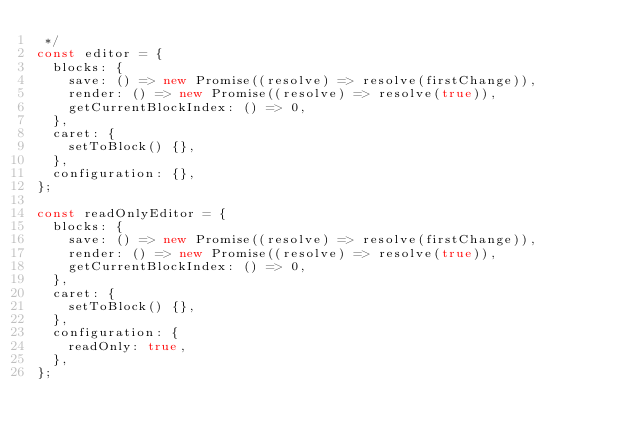Convert code to text. <code><loc_0><loc_0><loc_500><loc_500><_JavaScript_> */
const editor = {
  blocks: {
    save: () => new Promise((resolve) => resolve(firstChange)),
    render: () => new Promise((resolve) => resolve(true)),
    getCurrentBlockIndex: () => 0,
  },
  caret: {
    setToBlock() {},
  },
  configuration: {},
};

const readOnlyEditor = {
  blocks: {
    save: () => new Promise((resolve) => resolve(firstChange)),
    render: () => new Promise((resolve) => resolve(true)),
    getCurrentBlockIndex: () => 0,
  },
  caret: {
    setToBlock() {},
  },
  configuration: {
    readOnly: true,
  },
};
</code> 